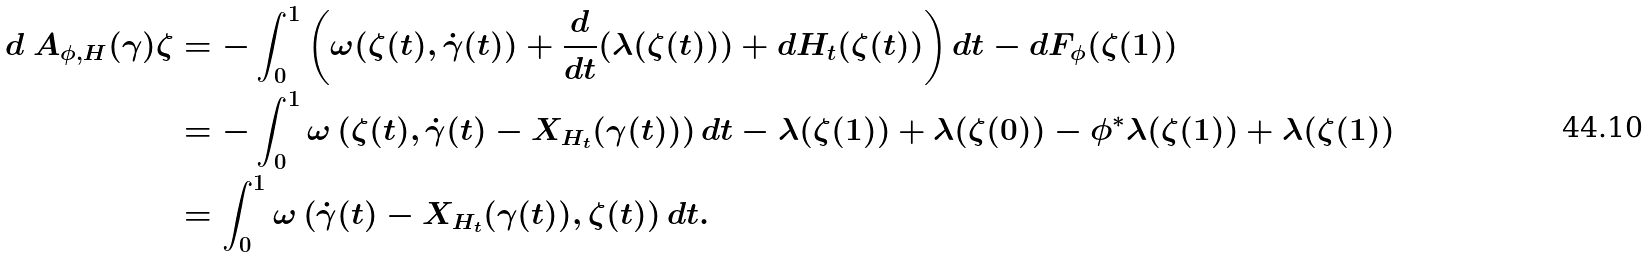<formula> <loc_0><loc_0><loc_500><loc_500>d \ A _ { \phi , H } ( \gamma ) \zeta & = - \int _ { 0 } ^ { 1 } \left ( \omega ( \zeta ( t ) , \dot { \gamma } ( t ) ) + \frac { d } { d t } ( \lambda ( \zeta ( t ) ) ) + d H _ { t } ( \zeta ( t ) ) \right ) d t - d F _ { \phi } ( \zeta ( 1 ) ) \\ & = - \int _ { 0 } ^ { 1 } \omega \left ( \zeta ( t ) , \dot { \gamma } ( t ) - X _ { H _ { t } } ( \gamma ( t ) ) \right ) d t - \lambda ( \zeta ( 1 ) ) + \lambda ( \zeta ( 0 ) ) - \phi ^ { \ast } \lambda ( \zeta ( 1 ) ) + \lambda ( \zeta ( 1 ) ) \\ & = \int _ { 0 } ^ { 1 } \omega \left ( \dot { \gamma } ( t ) - X _ { H _ { t } } ( \gamma ( t ) ) , \zeta ( t ) \right ) d t .</formula> 